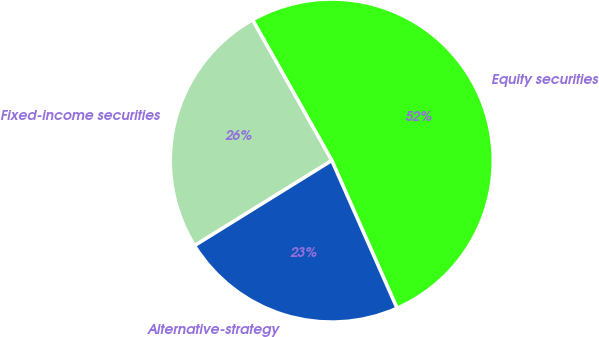Convert chart. <chart><loc_0><loc_0><loc_500><loc_500><pie_chart><fcel>Equity securities<fcel>Fixed-income securities<fcel>Alternative-strategy<nl><fcel>51.54%<fcel>25.67%<fcel>22.79%<nl></chart> 